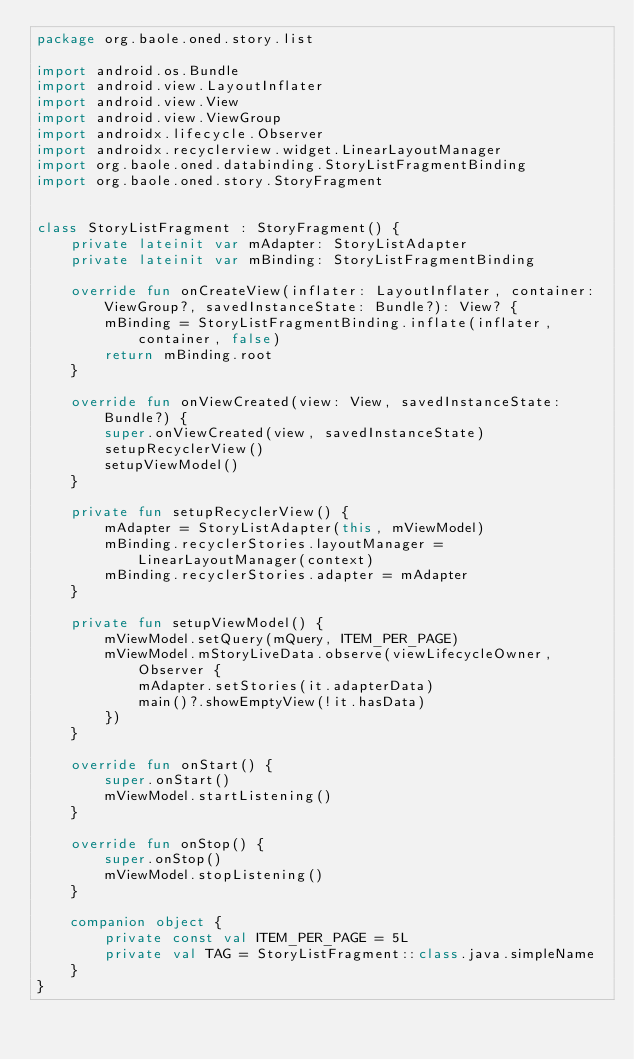Convert code to text. <code><loc_0><loc_0><loc_500><loc_500><_Kotlin_>package org.baole.oned.story.list

import android.os.Bundle
import android.view.LayoutInflater
import android.view.View
import android.view.ViewGroup
import androidx.lifecycle.Observer
import androidx.recyclerview.widget.LinearLayoutManager
import org.baole.oned.databinding.StoryListFragmentBinding
import org.baole.oned.story.StoryFragment


class StoryListFragment : StoryFragment() {
    private lateinit var mAdapter: StoryListAdapter
    private lateinit var mBinding: StoryListFragmentBinding

    override fun onCreateView(inflater: LayoutInflater, container: ViewGroup?, savedInstanceState: Bundle?): View? {
        mBinding = StoryListFragmentBinding.inflate(inflater, container, false)
        return mBinding.root
    }

    override fun onViewCreated(view: View, savedInstanceState: Bundle?) {
        super.onViewCreated(view, savedInstanceState)
        setupRecyclerView()
        setupViewModel()
    }

    private fun setupRecyclerView() {
        mAdapter = StoryListAdapter(this, mViewModel)
        mBinding.recyclerStories.layoutManager = LinearLayoutManager(context)
        mBinding.recyclerStories.adapter = mAdapter
    }

    private fun setupViewModel() {
        mViewModel.setQuery(mQuery, ITEM_PER_PAGE)
        mViewModel.mStoryLiveData.observe(viewLifecycleOwner, Observer {
            mAdapter.setStories(it.adapterData)
            main()?.showEmptyView(!it.hasData)
        })
    }

    override fun onStart() {
        super.onStart()
        mViewModel.startListening()
    }

    override fun onStop() {
        super.onStop()
        mViewModel.stopListening()
    }

    companion object {
        private const val ITEM_PER_PAGE = 5L
        private val TAG = StoryListFragment::class.java.simpleName
    }
}</code> 